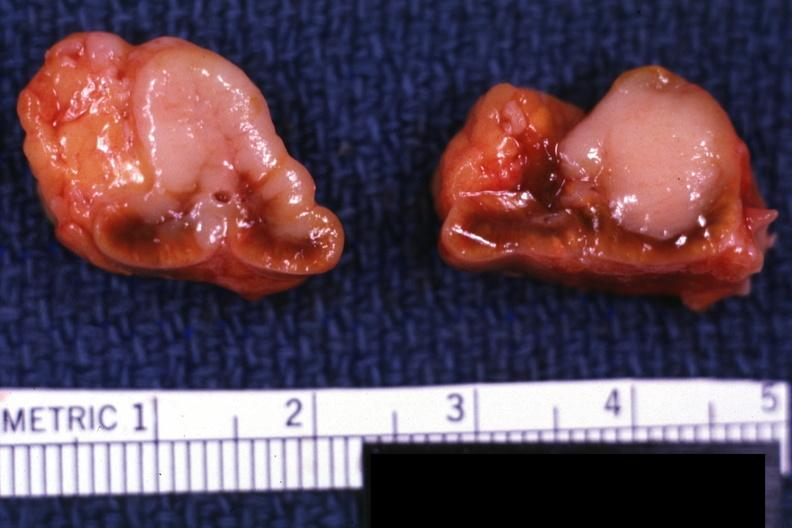what does this image show?
Answer the question using a single word or phrase. Metastatic carcinoma prostate 